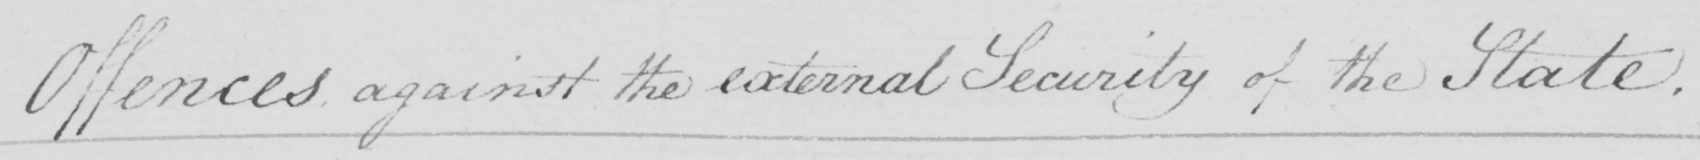Can you read and transcribe this handwriting? Offences against the external Security of the State . 